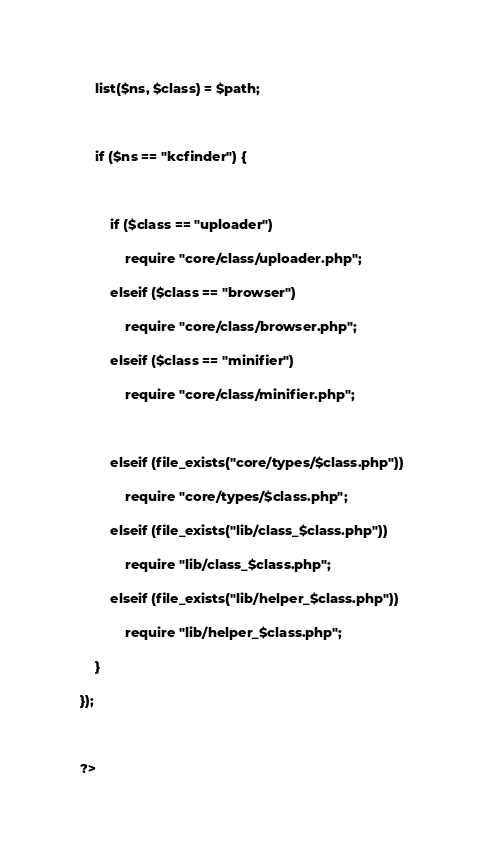<code> <loc_0><loc_0><loc_500><loc_500><_PHP_>
    list($ns, $class) = $path;

    if ($ns == "kcfinder") {

        if ($class == "uploader")
            require "core/class/uploader.php";
        elseif ($class == "browser")
            require "core/class/browser.php";
        elseif ($class == "minifier")
            require "core/class/minifier.php";

        elseif (file_exists("core/types/$class.php"))
            require "core/types/$class.php";
        elseif (file_exists("lib/class_$class.php"))
            require "lib/class_$class.php";
        elseif (file_exists("lib/helper_$class.php"))
            require "lib/helper_$class.php";
    }
});

?></code> 